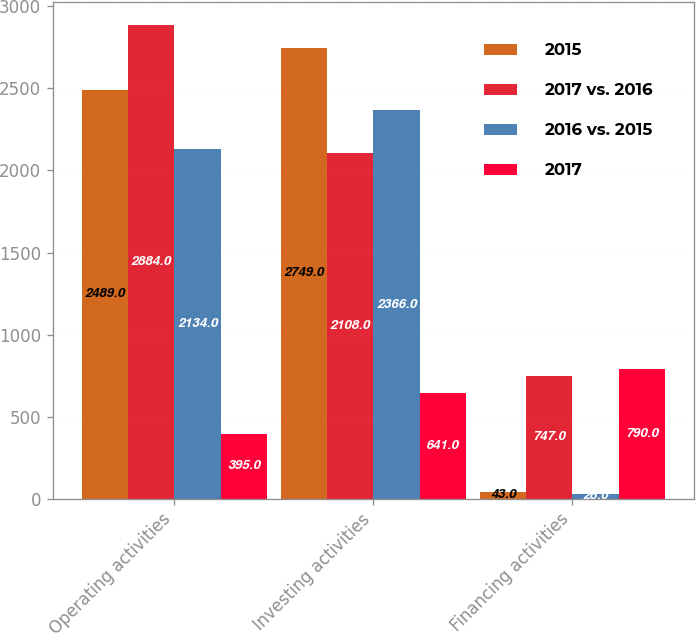<chart> <loc_0><loc_0><loc_500><loc_500><stacked_bar_chart><ecel><fcel>Operating activities<fcel>Investing activities<fcel>Financing activities<nl><fcel>2015<fcel>2489<fcel>2749<fcel>43<nl><fcel>2017 vs. 2016<fcel>2884<fcel>2108<fcel>747<nl><fcel>2016 vs. 2015<fcel>2134<fcel>2366<fcel>28<nl><fcel>2017<fcel>395<fcel>641<fcel>790<nl></chart> 